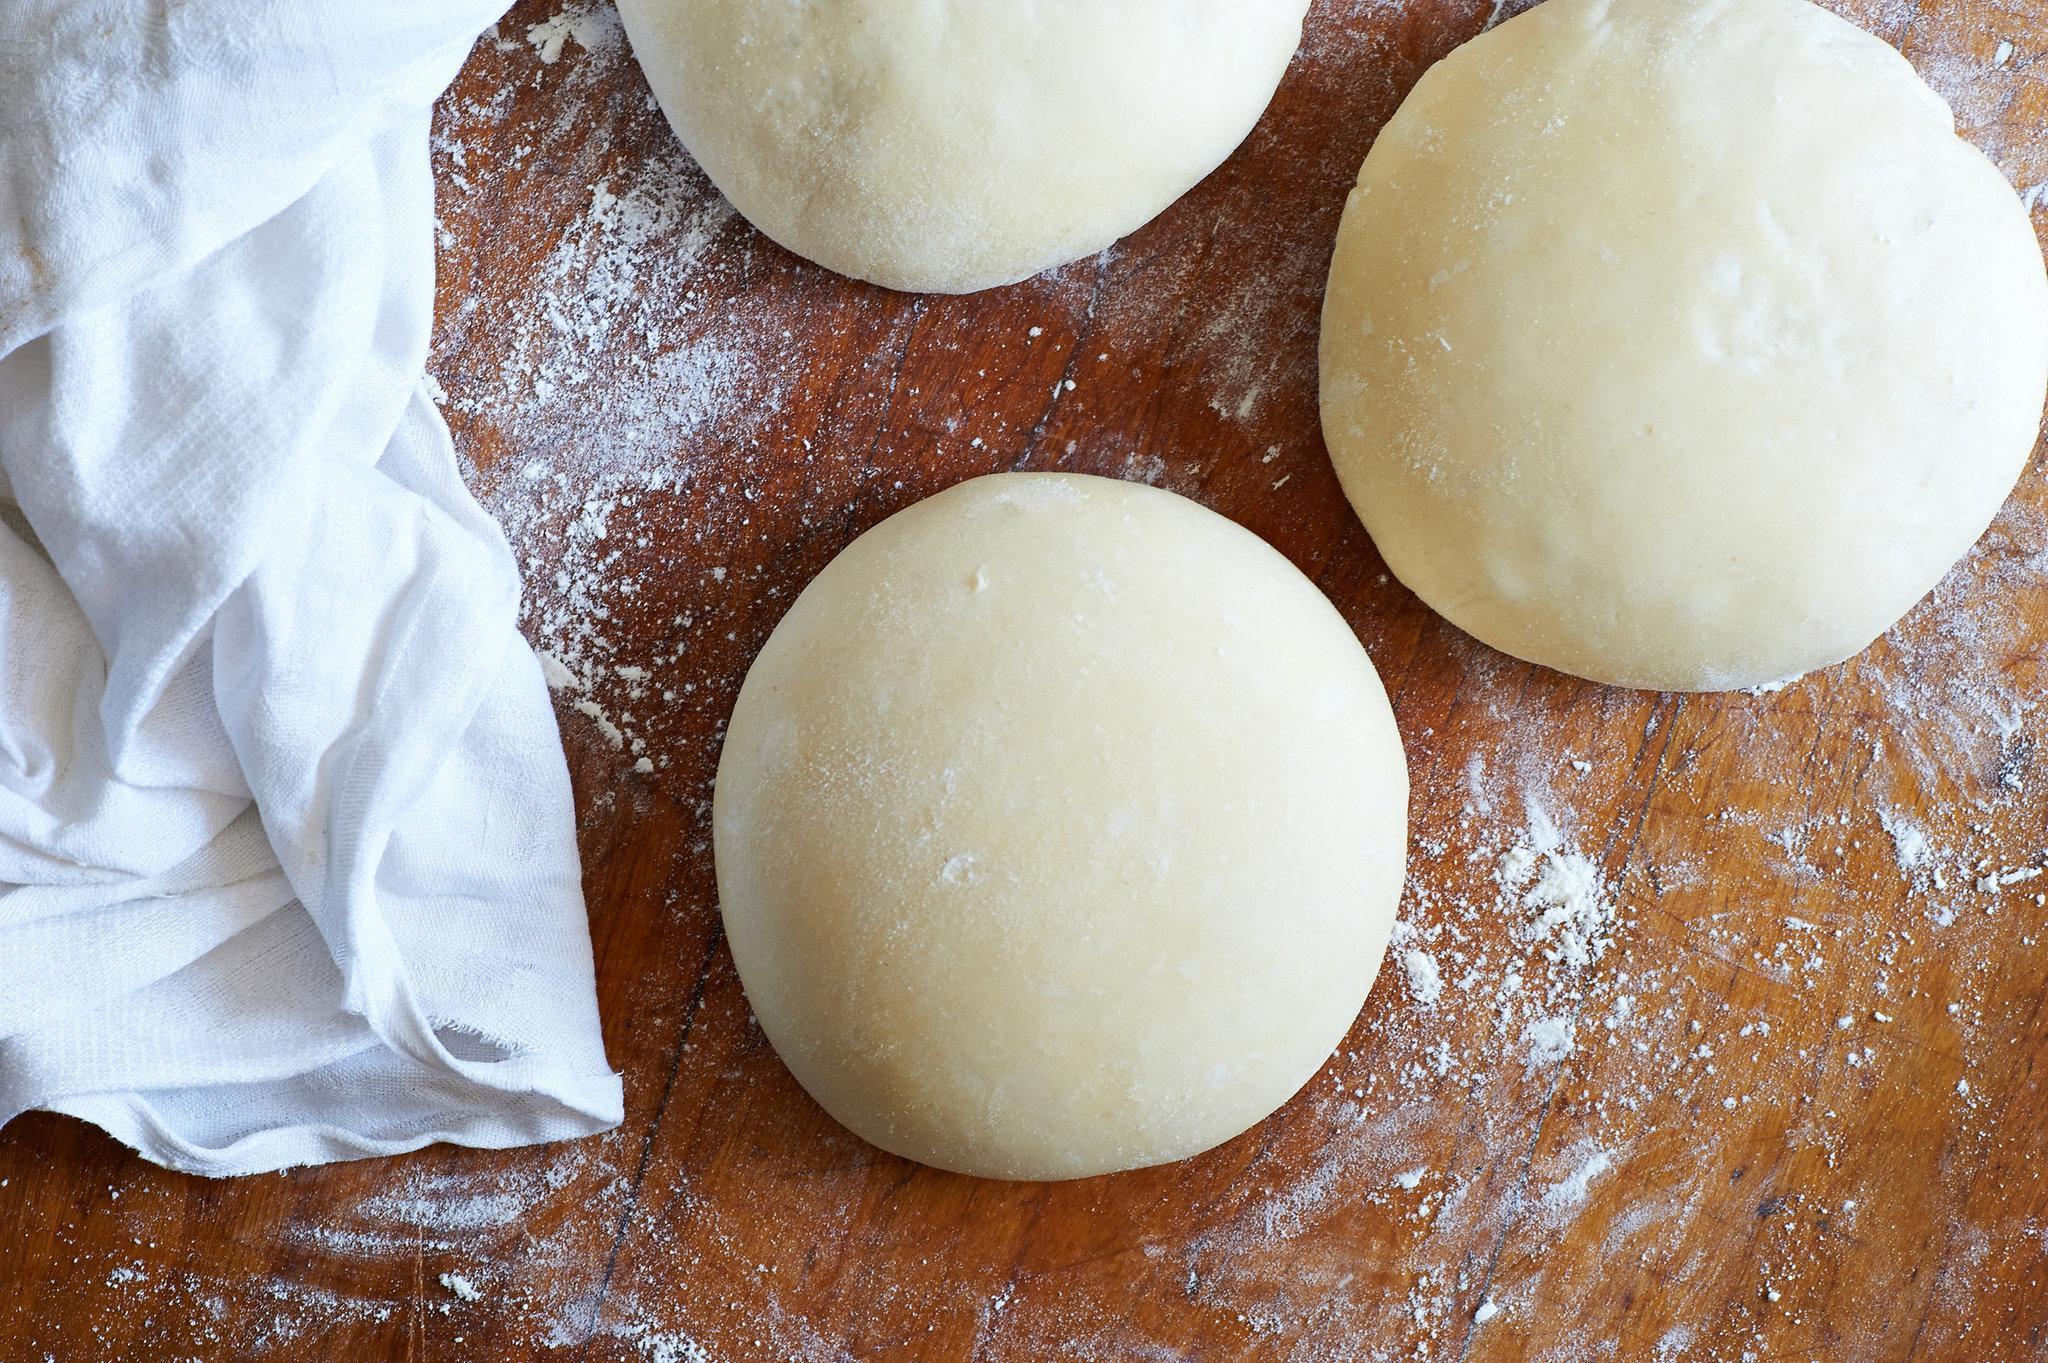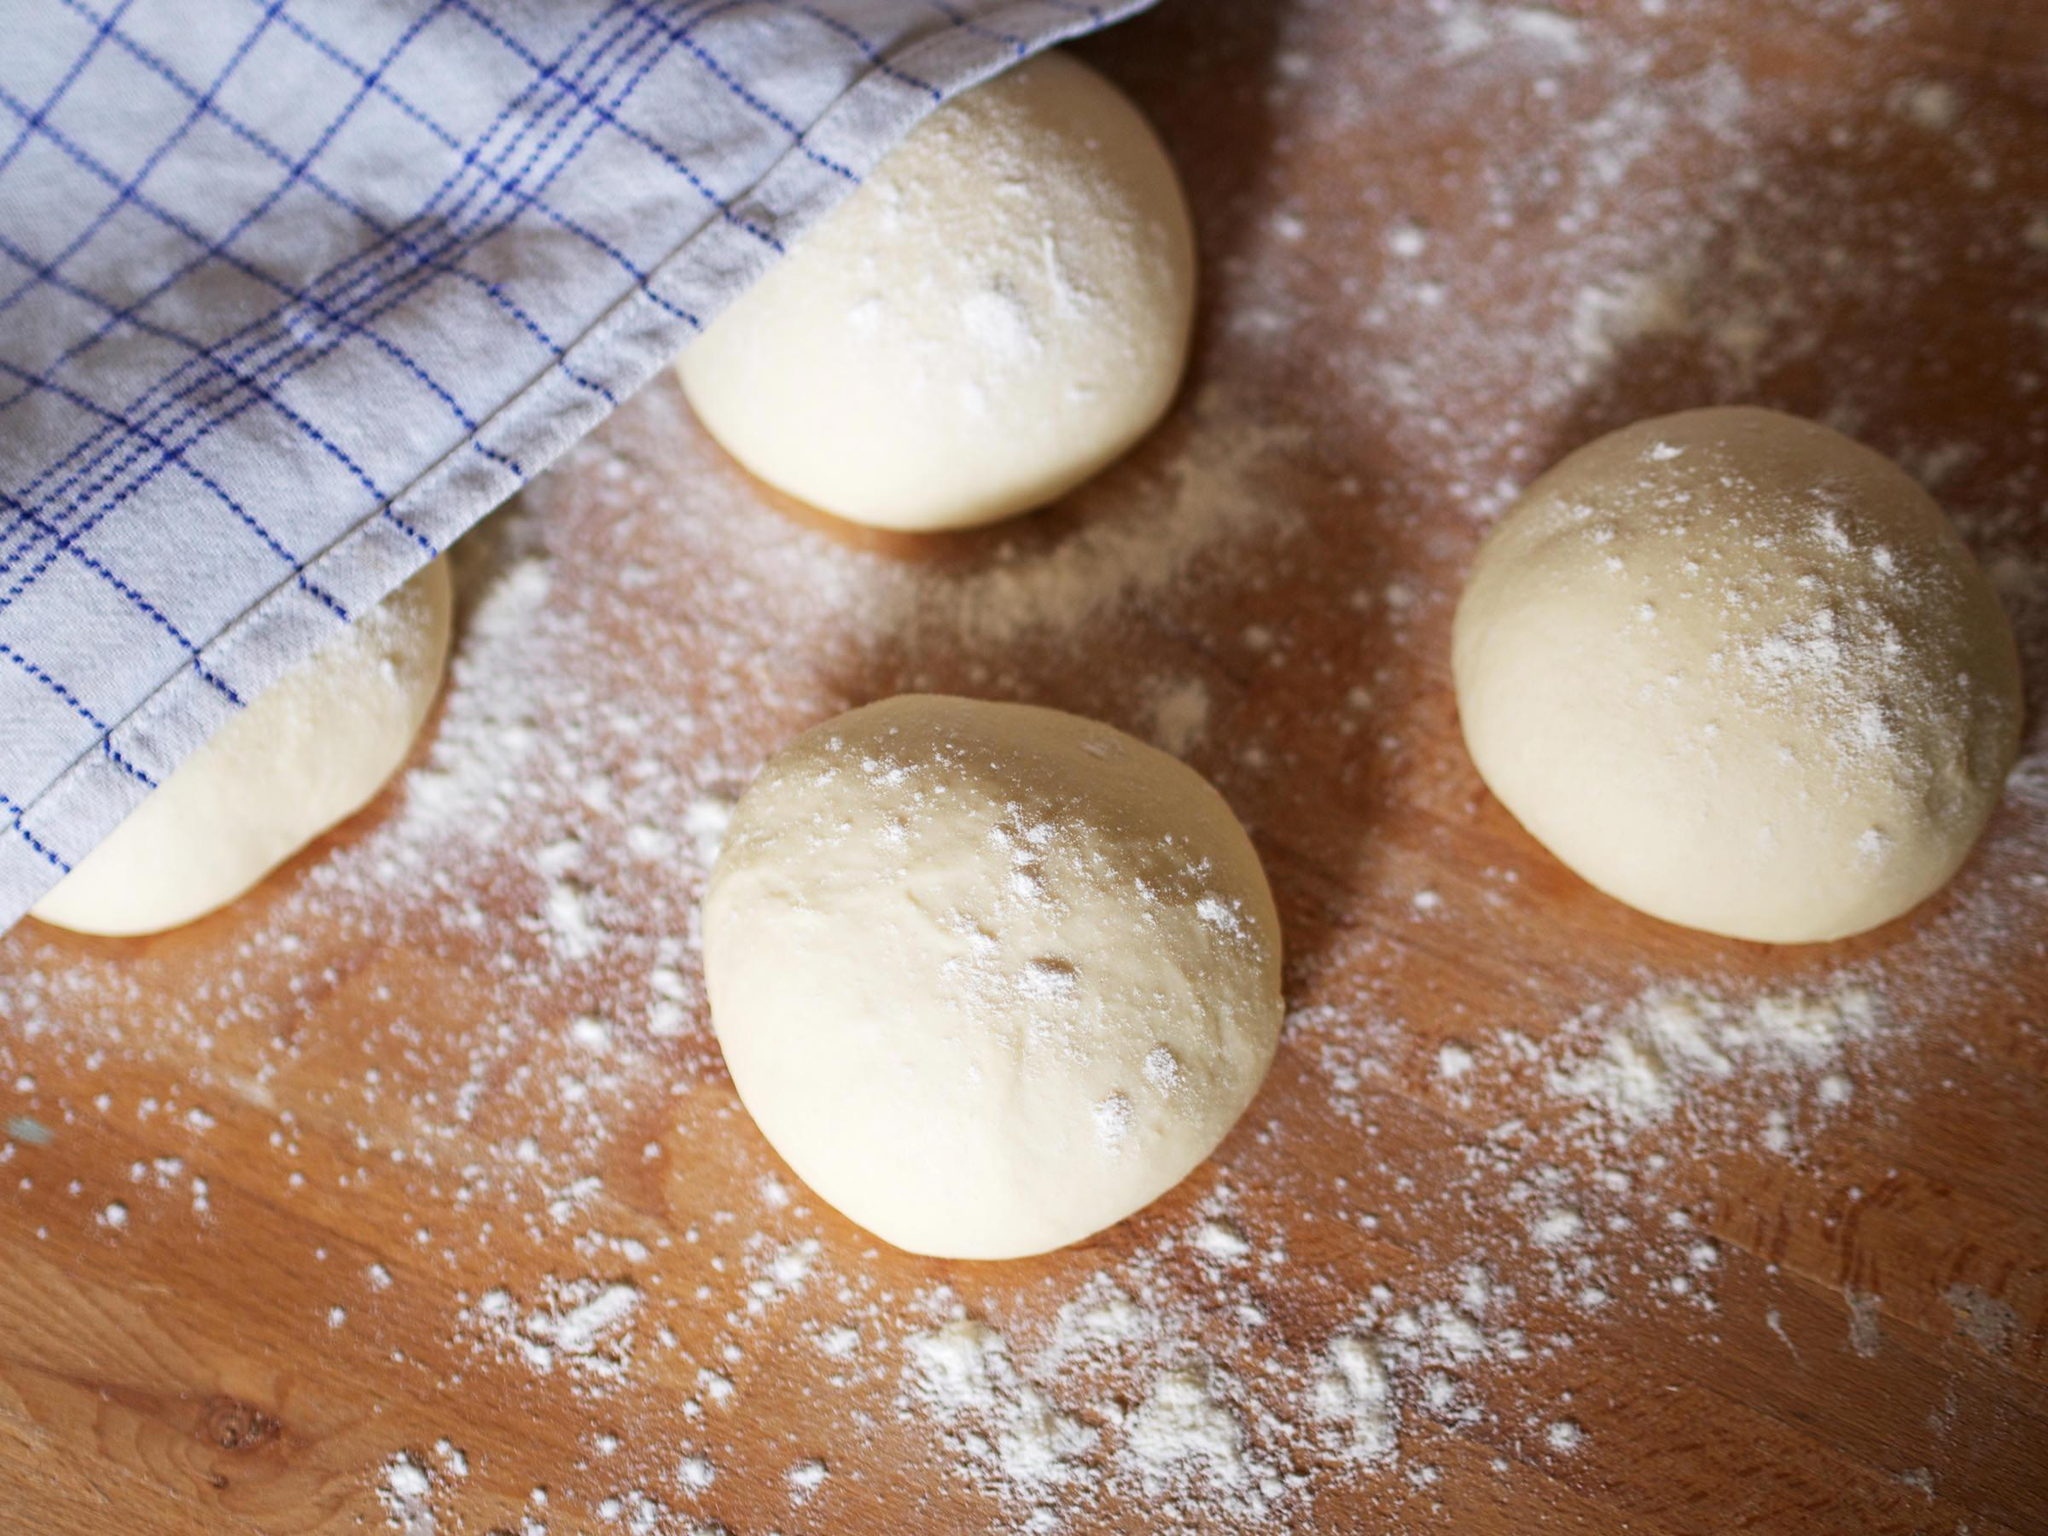The first image is the image on the left, the second image is the image on the right. Considering the images on both sides, is "There are exactly two balls of dough in one of the images." valid? Answer yes or no. No. 